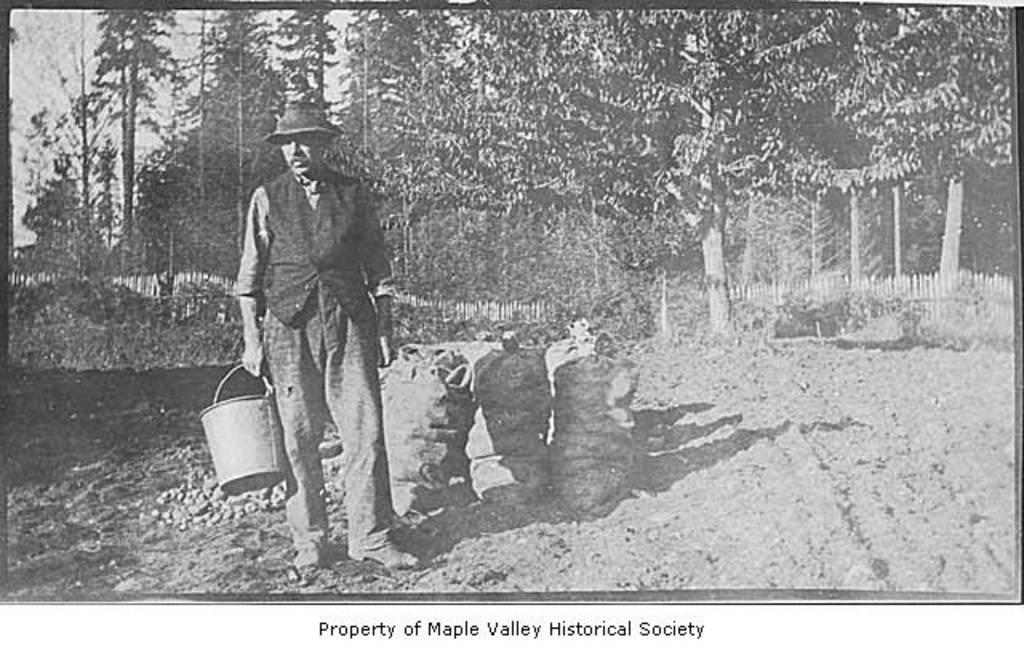What is the person in the image doing? The person is standing in the image and holding a bucket in his hand. What else can be seen near the person? There are three sack bags beside the person. What can be seen in the distance in the image? There are trees visible in the background of the image. What type of stick is the person using to perform magic in the image? There is no stick or magic present in the image; the person is simply holding a bucket and standing near sack bags. 